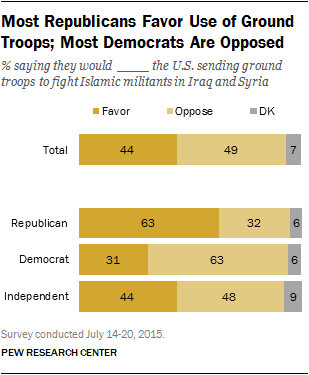Outline some significant characteristics in this image. The Republican party is more likely to support the use of ground troops. 